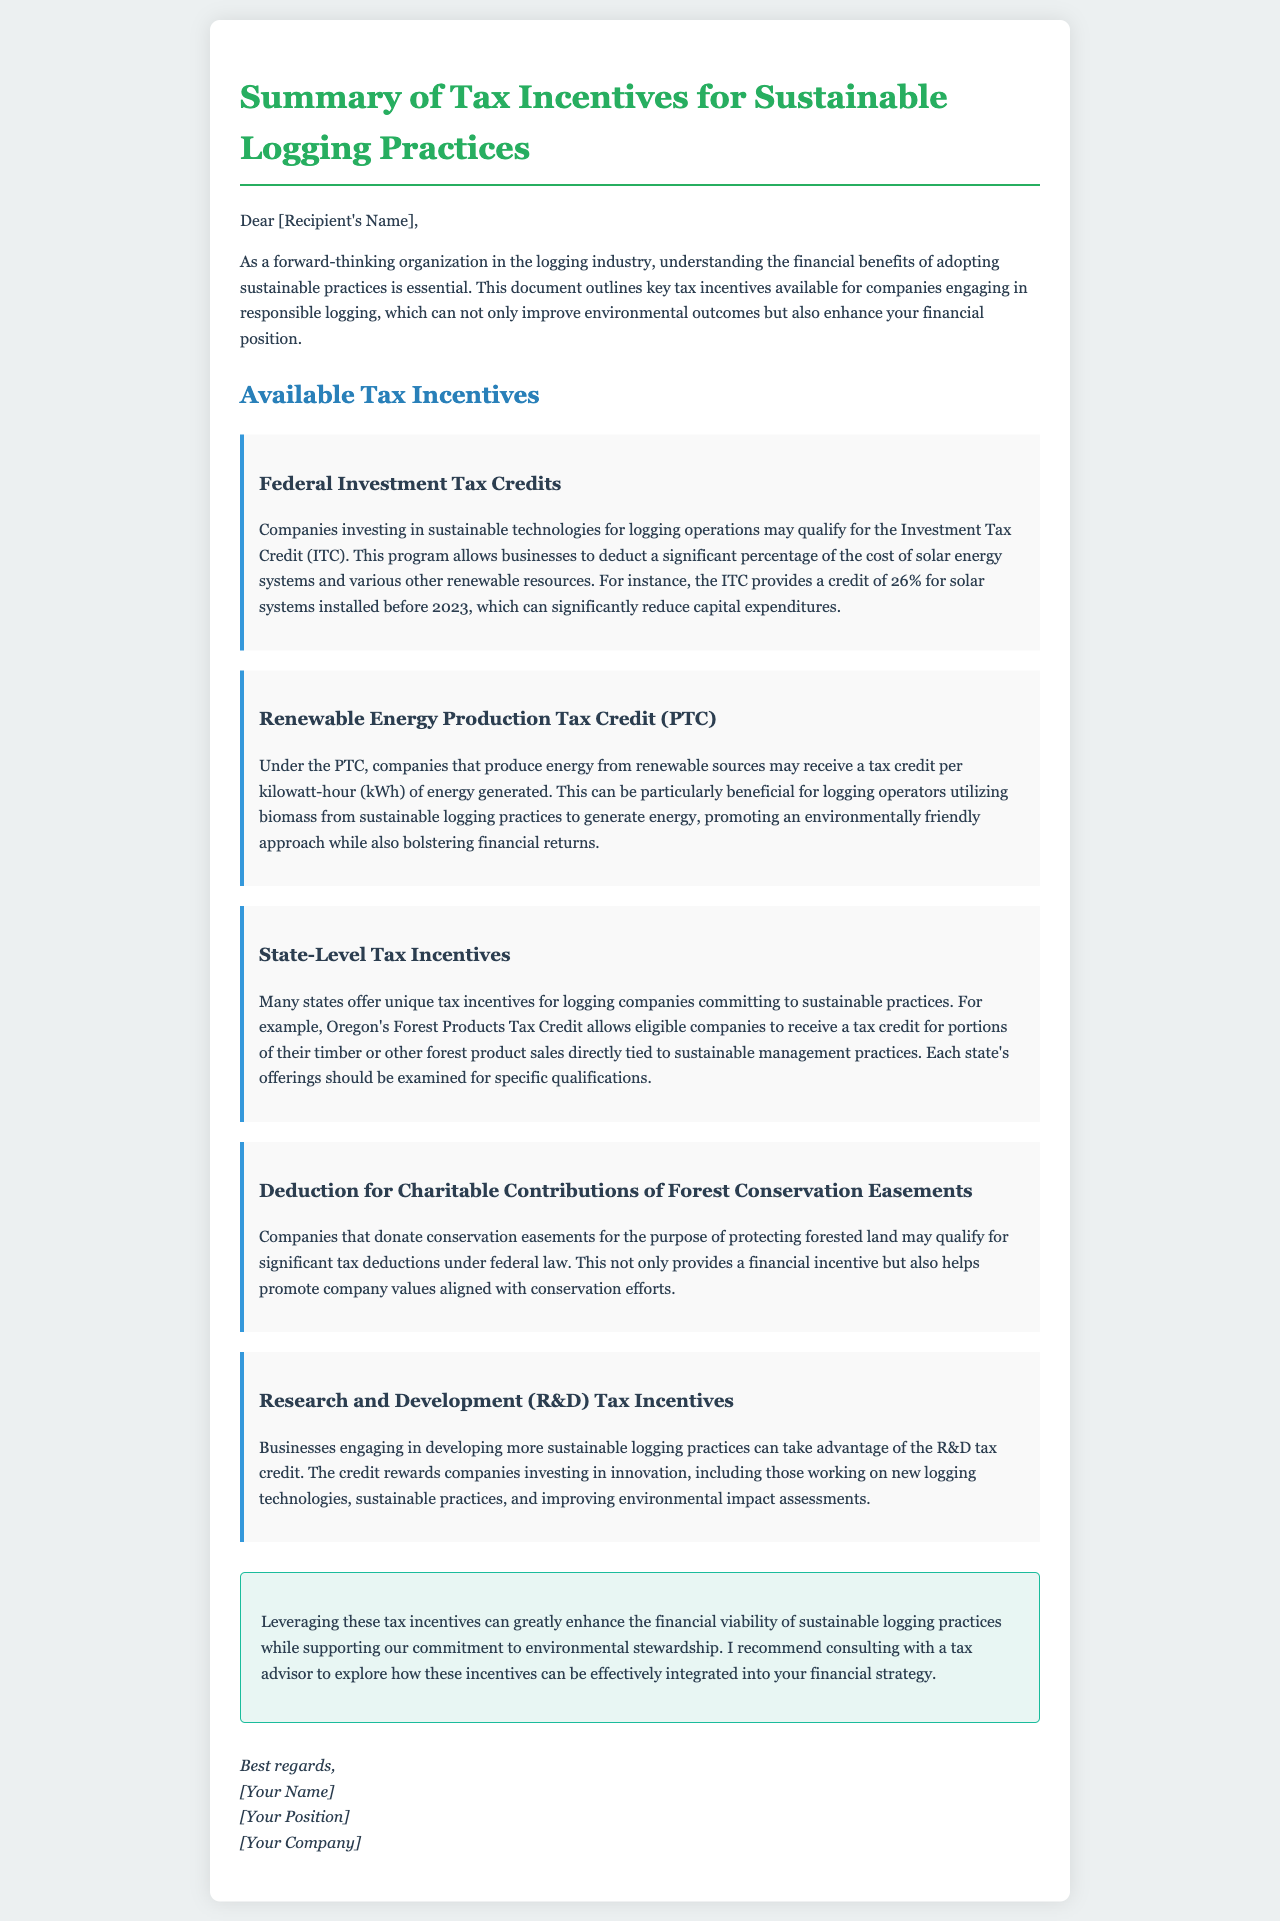What are Federal Investment Tax Credits? The document explains that companies investing in sustainable technologies for logging operations may qualify for the Investment Tax Credit (ITC).
Answer: Investment Tax Credit (ITC) What percentage does the ITC provide for solar systems installed before 2023? The document states that the ITC provides a credit of 26% for solar systems installed before 2023.
Answer: 26% What state offers Forest Products Tax Credit? According to the document, Oregon offers the Forest Products Tax Credit for companies committing to sustainable practices.
Answer: Oregon What is the tax benefit for donating conservation easements? The document mentions that companies that donate conservation easements may qualify for significant tax deductions under federal law.
Answer: Significant tax deductions What kind of credit does the Renewable Energy Production Tax Credit provide? The document explains that the PTC provides a tax credit per kilowatt-hour (kWh) of energy generated by companies producing energy from renewable sources.
Answer: per kilowatt-hour (kWh) Which companies can utilize R&D tax incentives? The document specifies that businesses engaging in developing more sustainable logging practices can take advantage of the R&D tax credit.
Answer: Businesses engaging in developing more sustainable logging practices What is the purpose of the document? The document outlines key tax incentives available for companies engaging in responsible logging that enhance financial position and improve environmental outcomes.
Answer: Outline key tax incentives Who should companies consult to explore these incentives? The document recommends consulting with a tax advisor to explore how these incentives can be effectively integrated into financial strategy.
Answer: A tax advisor 